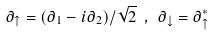<formula> <loc_0><loc_0><loc_500><loc_500>\partial _ { \uparrow } = ( \partial _ { 1 } - i \partial _ { 2 } ) / \sqrt { 2 } \ , \ \partial _ { \downarrow } = \partial _ { \uparrow } ^ { * }</formula> 